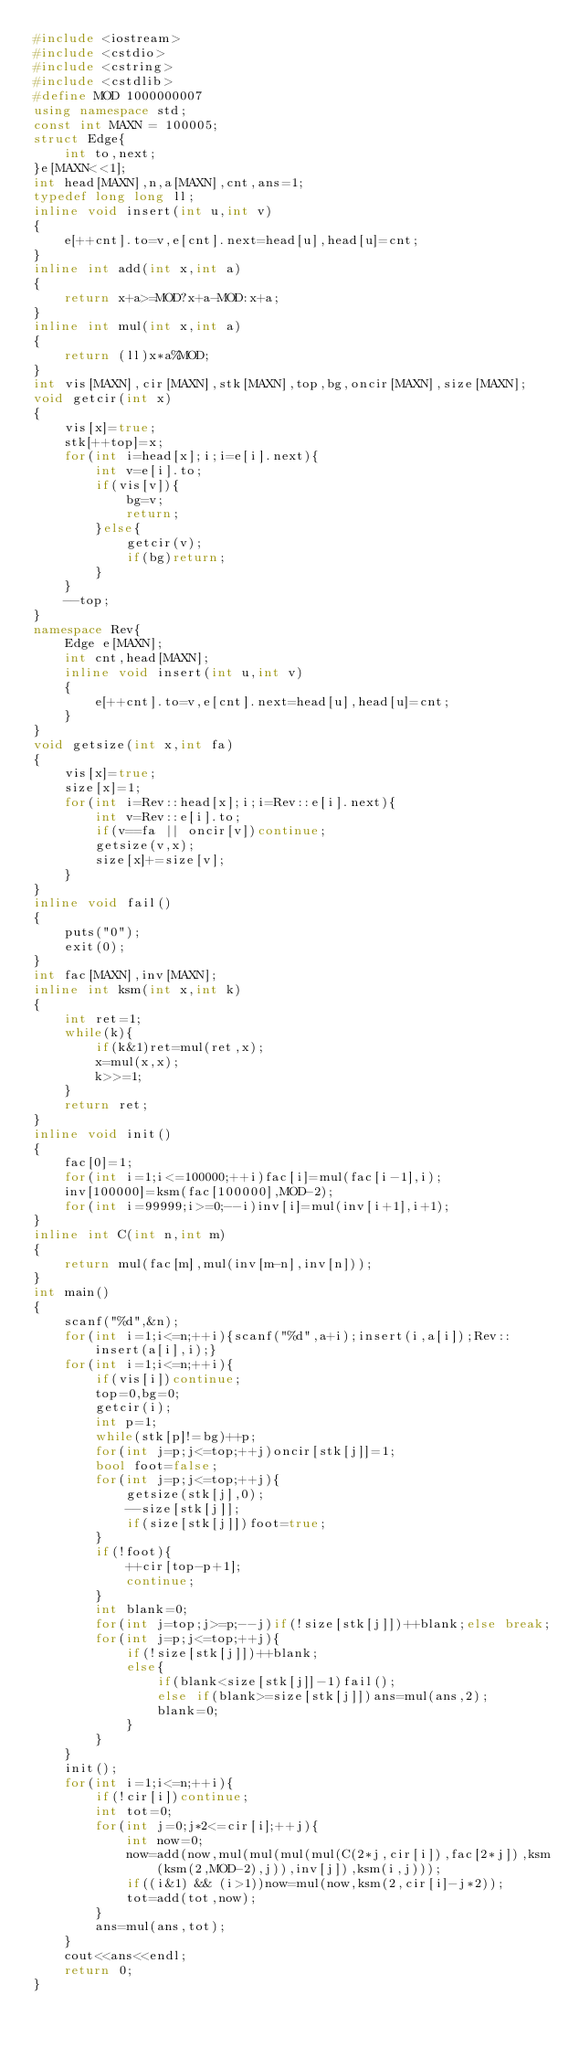<code> <loc_0><loc_0><loc_500><loc_500><_C++_>#include <iostream>
#include <cstdio>
#include <cstring>
#include <cstdlib>
#define MOD 1000000007
using namespace std;
const int MAXN = 100005;
struct Edge{
    int to,next;
}e[MAXN<<1];
int head[MAXN],n,a[MAXN],cnt,ans=1;
typedef long long ll;
inline void insert(int u,int v)
{
    e[++cnt].to=v,e[cnt].next=head[u],head[u]=cnt;
}
inline int add(int x,int a)
{
    return x+a>=MOD?x+a-MOD:x+a;
}
inline int mul(int x,int a)
{
    return (ll)x*a%MOD;
}
int vis[MAXN],cir[MAXN],stk[MAXN],top,bg,oncir[MAXN],size[MAXN];
void getcir(int x)
{
    vis[x]=true;
    stk[++top]=x;
    for(int i=head[x];i;i=e[i].next){
        int v=e[i].to;
        if(vis[v]){
            bg=v;
            return;
        }else{
            getcir(v);
            if(bg)return;
        }
    }
    --top;
}
namespace Rev{
    Edge e[MAXN];
    int cnt,head[MAXN];
    inline void insert(int u,int v)
    {
        e[++cnt].to=v,e[cnt].next=head[u],head[u]=cnt;
    }
}
void getsize(int x,int fa)
{
    vis[x]=true;
    size[x]=1;
    for(int i=Rev::head[x];i;i=Rev::e[i].next){
        int v=Rev::e[i].to;
        if(v==fa || oncir[v])continue;
        getsize(v,x);
        size[x]+=size[v];
    }
}
inline void fail()
{
    puts("0");
    exit(0);
}
int fac[MAXN],inv[MAXN];
inline int ksm(int x,int k)
{
    int ret=1;
    while(k){
        if(k&1)ret=mul(ret,x);
        x=mul(x,x);
        k>>=1;
    }
    return ret;
}
inline void init()
{
    fac[0]=1;
    for(int i=1;i<=100000;++i)fac[i]=mul(fac[i-1],i);
    inv[100000]=ksm(fac[100000],MOD-2);
    for(int i=99999;i>=0;--i)inv[i]=mul(inv[i+1],i+1);
}
inline int C(int n,int m)
{
    return mul(fac[m],mul(inv[m-n],inv[n]));
}
int main()
{
    scanf("%d",&n);
    for(int i=1;i<=n;++i){scanf("%d",a+i);insert(i,a[i]);Rev::insert(a[i],i);}
    for(int i=1;i<=n;++i){
        if(vis[i])continue;
        top=0,bg=0;
        getcir(i);
        int p=1;
        while(stk[p]!=bg)++p;
        for(int j=p;j<=top;++j)oncir[stk[j]]=1;
        bool foot=false;
        for(int j=p;j<=top;++j){
            getsize(stk[j],0);
            --size[stk[j]];
            if(size[stk[j]])foot=true;
        }
        if(!foot){
            ++cir[top-p+1];
            continue;
        }
        int blank=0;
        for(int j=top;j>=p;--j)if(!size[stk[j]])++blank;else break;
        for(int j=p;j<=top;++j){
            if(!size[stk[j]])++blank;
            else{
                if(blank<size[stk[j]]-1)fail();
                else if(blank>=size[stk[j]])ans=mul(ans,2);
                blank=0;
            }
        }
    }
    init();
    for(int i=1;i<=n;++i){
        if(!cir[i])continue;
        int tot=0;
        for(int j=0;j*2<=cir[i];++j){
            int now=0;
            now=add(now,mul(mul(mul(mul(C(2*j,cir[i]),fac[2*j]),ksm(ksm(2,MOD-2),j)),inv[j]),ksm(i,j)));
            if((i&1) && (i>1))now=mul(now,ksm(2,cir[i]-j*2));
            tot=add(tot,now);
        }
        ans=mul(ans,tot);
    }
    cout<<ans<<endl;
    return 0;
}
</code> 